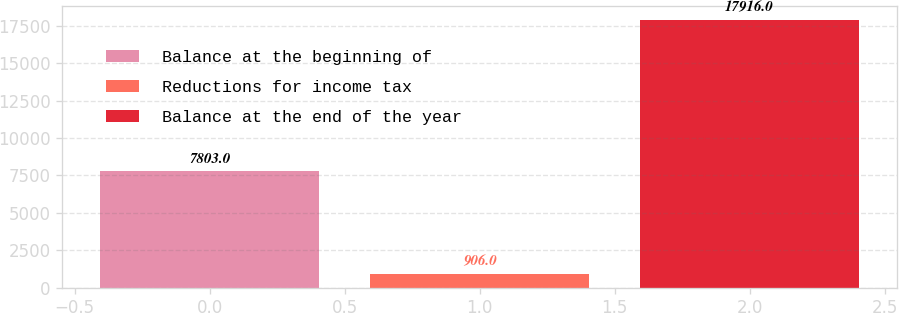<chart> <loc_0><loc_0><loc_500><loc_500><bar_chart><fcel>Balance at the beginning of<fcel>Reductions for income tax<fcel>Balance at the end of the year<nl><fcel>7803<fcel>906<fcel>17916<nl></chart> 